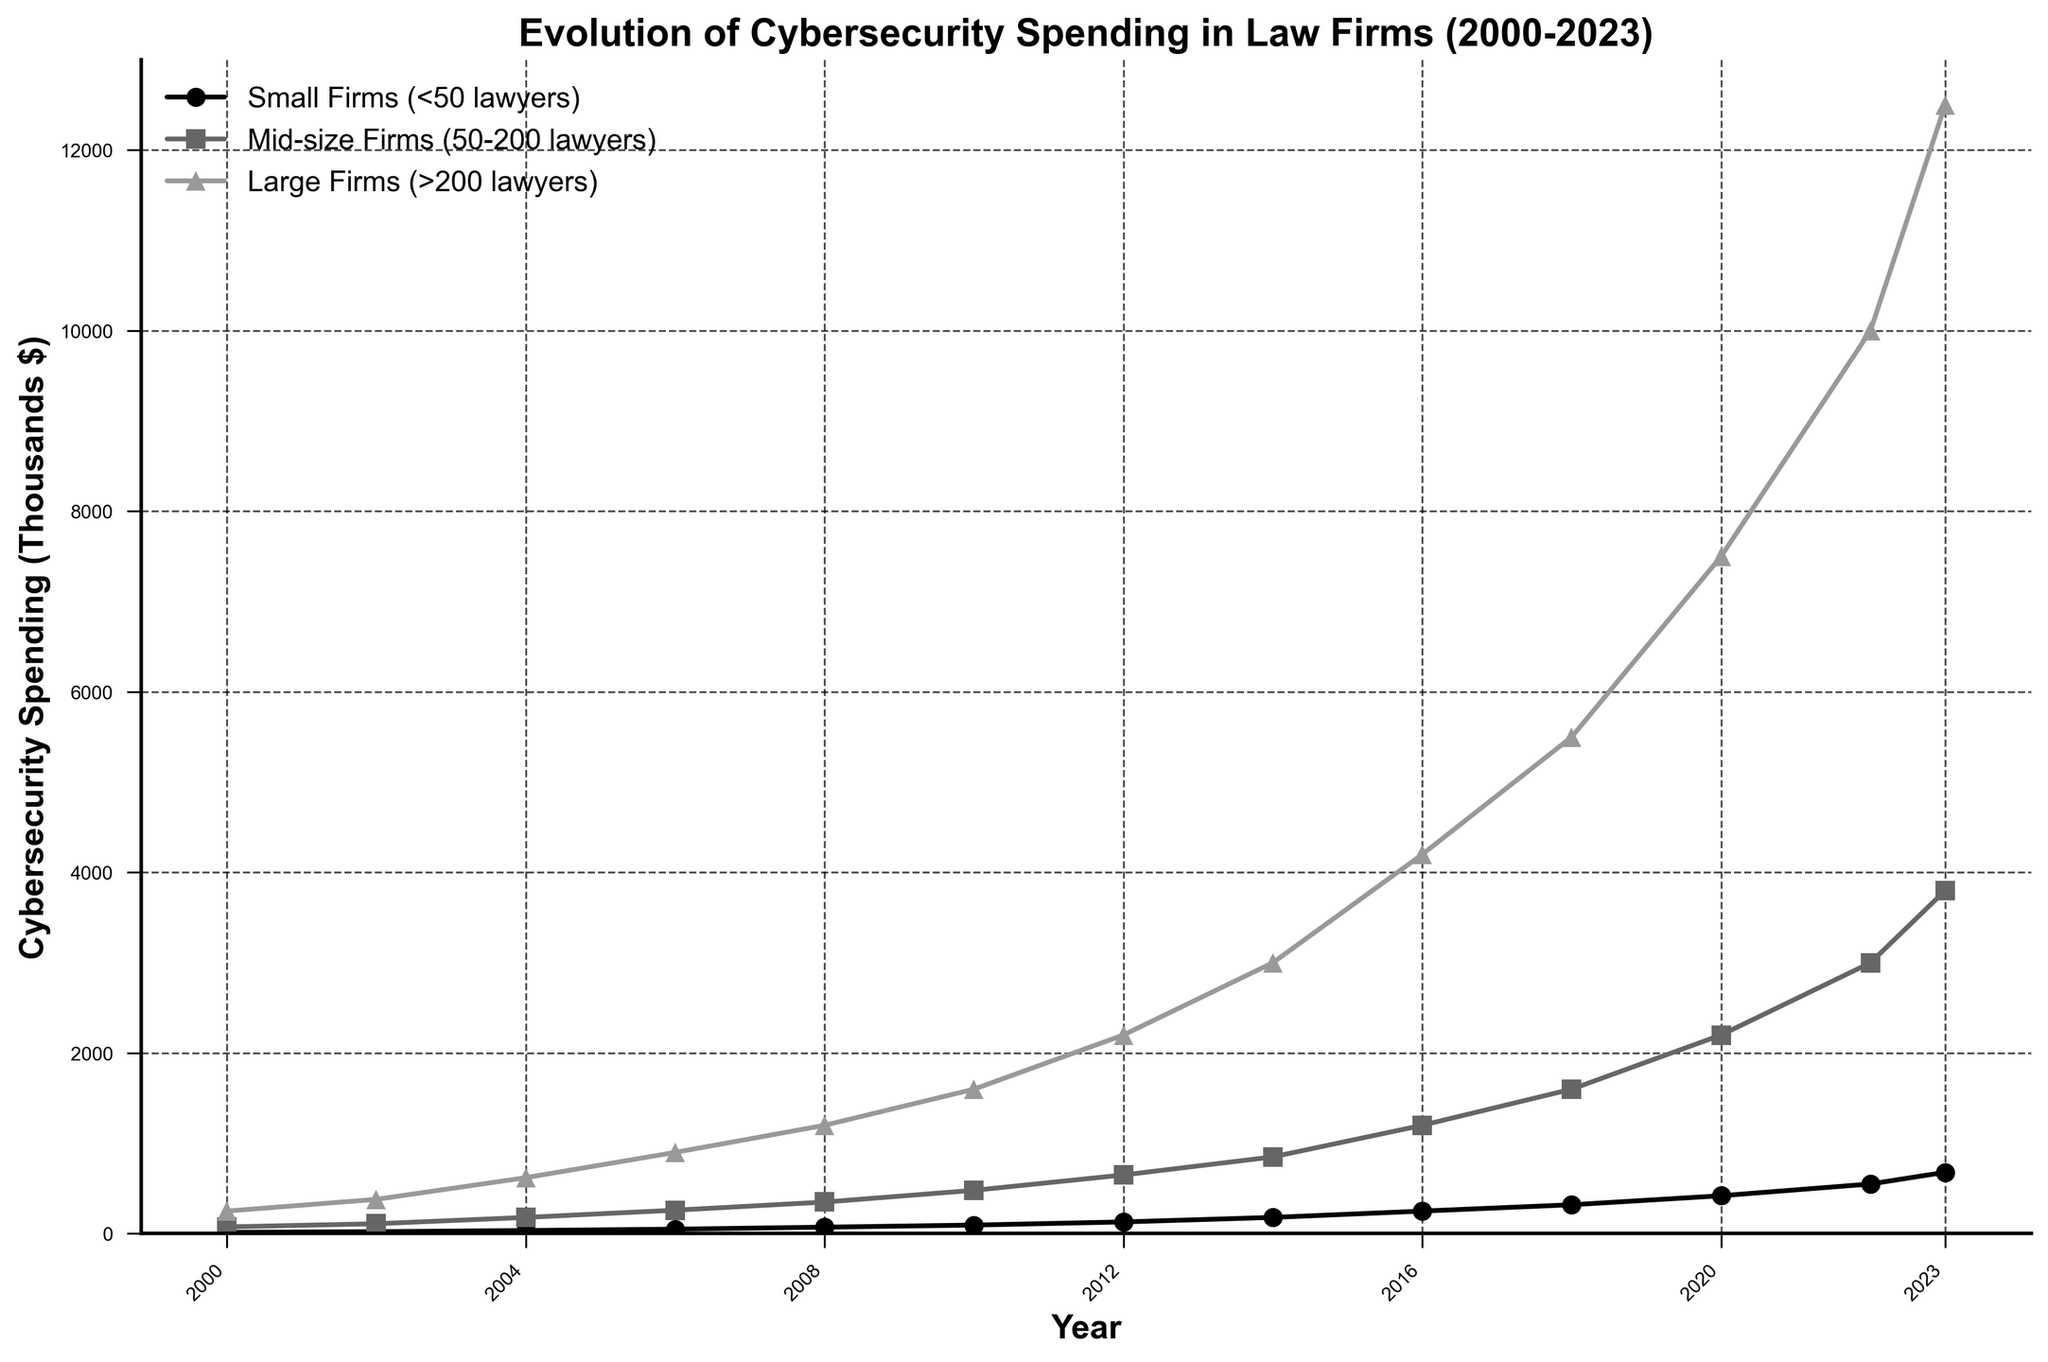What is the cybersecurity spending for small firms in 2020? Locate the data point for small firms on the line chart for the year 2020, and note the value.
Answer: $420,000 Which type of law firm shows the highest spending on cybersecurity in 2023? Compare the cybersecurity spending of small, mid-size, and large firms for the year 2023 by looking at their respective lines on the chart.
Answer: Large Firms How much more did mid-size firms spend on cybersecurity in 2018 compared to 2012? Find the cybersecurity spending for mid-size firms in 2018 and 2012 on the chart. Subtract the 2012 value from the 2018 value.
Answer: $950,000 In which year did small firms surpass $100,000 in cybersecurity spending? Identify the year where the line representing small firms crosses the $100,000 mark on the y-axis for the first time.
Answer: 2010 What is the difference in cybersecurity spending between large firms and small firms in 2006? Find the cybersecurity spending for large firms and small firms in 2006 on the chart and subtract the small firms’ value from large firms’ value.
Answer: $850,000 How has the spending of mid-size firms on cybersecurity evolved between 2000 and 2023? Analyze the trend line for mid-size firms from 2000 to 2023 on the chart. It shows the changes in cybersecurity spending over time.
Answer: Steadily increased By how much did the cybersecurity spending of large firms increase from 2002 to 2008? Locate the data points for large firms in 2008 and 2002 on the chart, then subtract the 2002 value from the 2008 value.
Answer: $820,000 Which category of firms had the sharpest increase in cybersecurity spending between 2014 and 2016? Compare the slopes of the lines for each category of firms between the years 2014 and 2016. The steepest slope indicates the sharpest increase.
Answer: Large Firms What were the cybersecurity spending values for mid-size firms in 2016 and 2018, and what is their average? Find the spending values for mid-size firms in 2016 and 2018 on the chart. Calculate the average of these two values. (1200000 + 1600000) / 2 = 1400000
Answer: $1,400,000 In what year did large firms spend 5 times more on cybersecurity than small firms? Look for a year where the spending value for large firms is approximately 5 times that of small firms.
Answer: 2008 